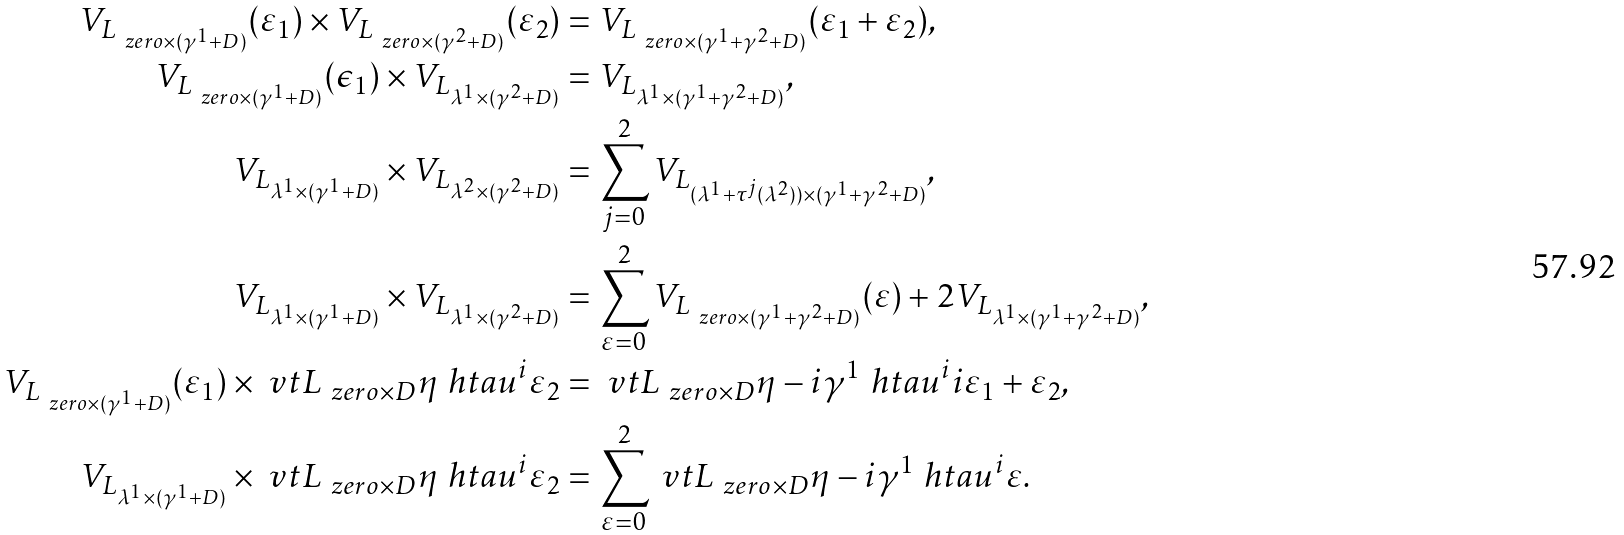Convert formula to latex. <formula><loc_0><loc_0><loc_500><loc_500>V _ { L _ { \ z e r o \times ( \gamma ^ { 1 } + D ) } } ( \varepsilon _ { 1 } ) \times V _ { L _ { \ z e r o \times ( \gamma ^ { 2 } + D ) } } ( \varepsilon _ { 2 } ) & = V _ { L _ { \ z e r o \times ( \gamma ^ { 1 } + \gamma ^ { 2 } + D ) } } ( \varepsilon _ { 1 } + \varepsilon _ { 2 } ) , \\ V _ { L _ { \ z e r o \times ( \gamma ^ { 1 } + D ) } } ( \epsilon _ { 1 } ) \times V _ { L _ { \lambda ^ { 1 } \times ( \gamma ^ { 2 } + D ) } } & = V _ { L _ { \lambda ^ { 1 } \times ( \gamma ^ { 1 } + \gamma ^ { 2 } + D ) } } , \\ V _ { L _ { \lambda ^ { 1 } \times ( \gamma ^ { 1 } + D ) } } \times V _ { L _ { \lambda ^ { 2 } \times ( \gamma ^ { 2 } + D ) } } & = \sum _ { j = 0 } ^ { 2 } V _ { L _ { ( \lambda ^ { 1 } + \tau ^ { j } ( \lambda ^ { 2 } ) ) \times ( \gamma ^ { 1 } + \gamma ^ { 2 } + D ) } } , \\ V _ { L _ { \lambda ^ { 1 } \times ( \gamma ^ { 1 } + D ) } } \times V _ { L _ { \lambda ^ { 1 } \times ( \gamma ^ { 2 } + D ) } } & = \sum _ { \varepsilon = 0 } ^ { 2 } V _ { L _ { \ z e r o \times ( \gamma ^ { 1 } + \gamma ^ { 2 } + D ) } } ( \varepsilon ) + 2 V _ { L _ { \lambda ^ { 1 } \times ( \gamma ^ { 1 } + \gamma ^ { 2 } + D ) } } , \\ V _ { L _ { \ z e r o \times ( \gamma ^ { 1 } + D ) } } ( \varepsilon _ { 1 } ) \times \ v t { L _ { \ z e r o \times D } } { \eta } { \ h t a u ^ { i } } { \varepsilon _ { 2 } } & = \ v t { L _ { \ z e r o \times D } } { \eta - i \gamma ^ { 1 } } { \ h t a u ^ { i } } { i \varepsilon _ { 1 } + \varepsilon _ { 2 } } , \\ V _ { L _ { \lambda ^ { 1 } \times ( \gamma ^ { 1 } + D ) } } \times \ v t { L _ { \ z e r o \times D } } { \eta } { \ h t a u ^ { i } } { \varepsilon _ { 2 } } & = \sum _ { \varepsilon = 0 } ^ { 2 } \ v t { L _ { \ z e r o \times D } } { \eta - i \gamma ^ { 1 } } { \ h t a u ^ { i } } { \varepsilon } .</formula> 